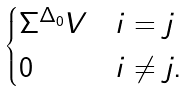<formula> <loc_0><loc_0><loc_500><loc_500>\begin{cases} \Sigma ^ { \Delta _ { 0 } } V & i = j \\ 0 & i \ne j . \end{cases}</formula> 